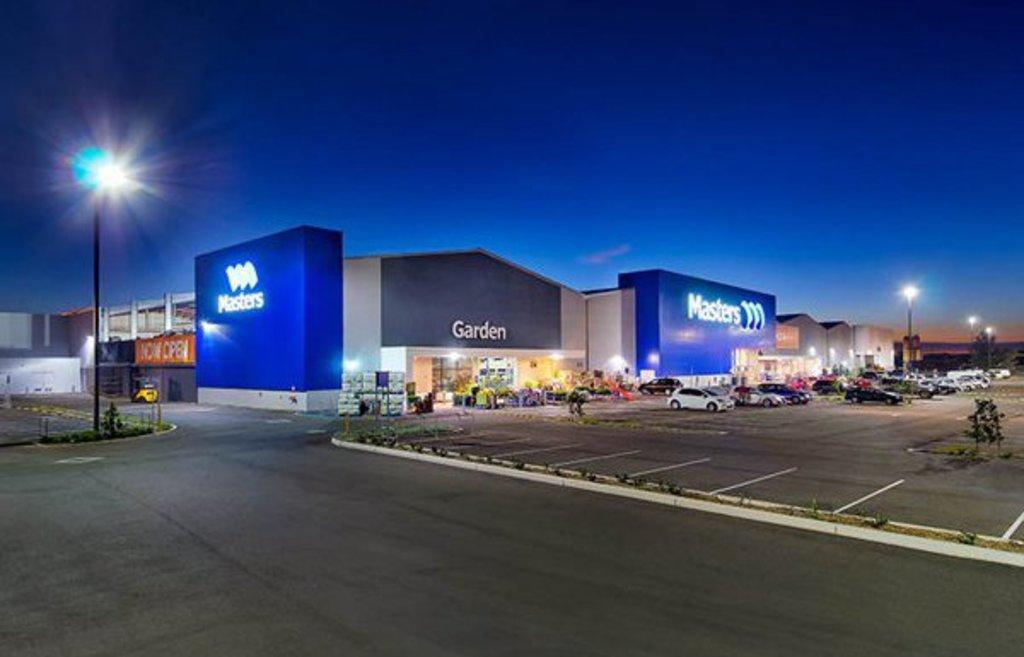What type of buildings can be seen in the image? There are warehouses in the image. What other objects can be seen in the image besides the warehouses? There are street poles and vehicles visible in the image. Where are the vehicles located in the image? The vehicles are on the right side of the image. What is visible at the top of the image? The sky is visible at the top of the image. How many zippers can be seen on the stocking in the image? There is no stocking or zipper present in the image. What type of push can be seen in the image? There is no pushable object or action present in the image. 